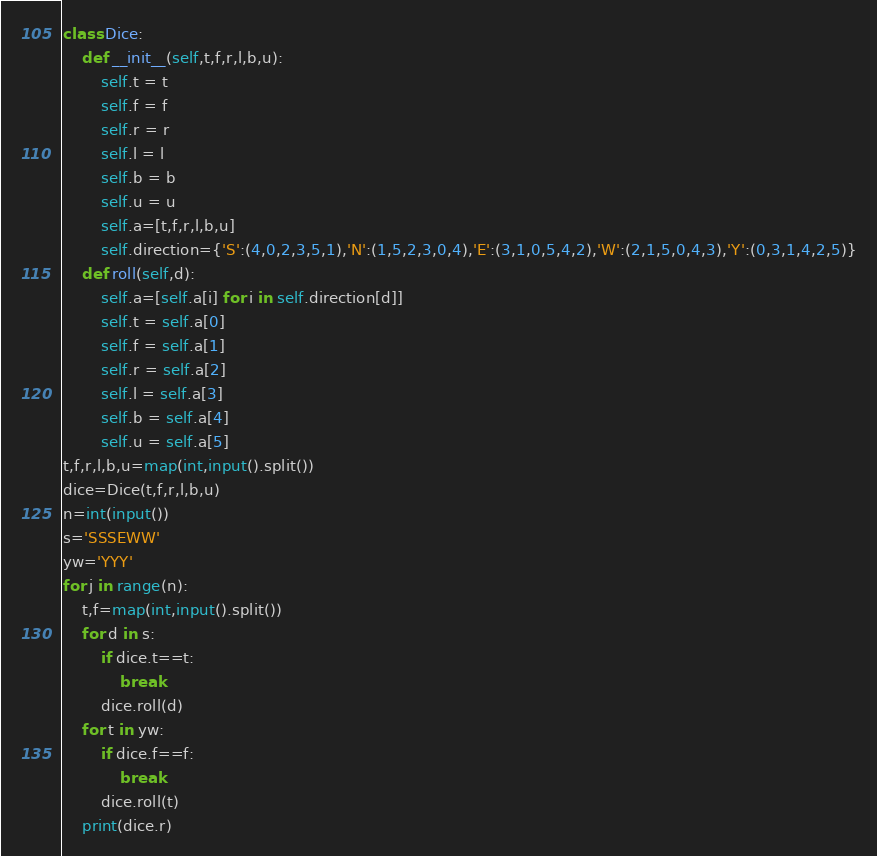Convert code to text. <code><loc_0><loc_0><loc_500><loc_500><_Python_>class Dice:
    def __init__(self,t,f,r,l,b,u):
        self.t = t
        self.f = f
        self.r = r
        self.l = l
        self.b = b
        self.u = u
        self.a=[t,f,r,l,b,u]
        self.direction={'S':(4,0,2,3,5,1),'N':(1,5,2,3,0,4),'E':(3,1,0,5,4,2),'W':(2,1,5,0,4,3),'Y':(0,3,1,4,2,5)}
    def roll(self,d):
        self.a=[self.a[i] for i in self.direction[d]]
        self.t = self.a[0]
        self.f = self.a[1]
        self.r = self.a[2]
        self.l = self.a[3]
        self.b = self.a[4]
        self.u = self.a[5]
t,f,r,l,b,u=map(int,input().split())
dice=Dice(t,f,r,l,b,u)
n=int(input())
s='SSSEWW'
yw='YYY'
for j in range(n):
    t,f=map(int,input().split())
    for d in s:
        if dice.t==t:
            break
        dice.roll(d)
    for t in yw:
        if dice.f==f:
            break
        dice.roll(t)
    print(dice.r)
</code> 